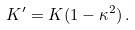<formula> <loc_0><loc_0><loc_500><loc_500>K ^ { \prime } = K ( 1 - \kappa ^ { 2 } ) \, .</formula> 